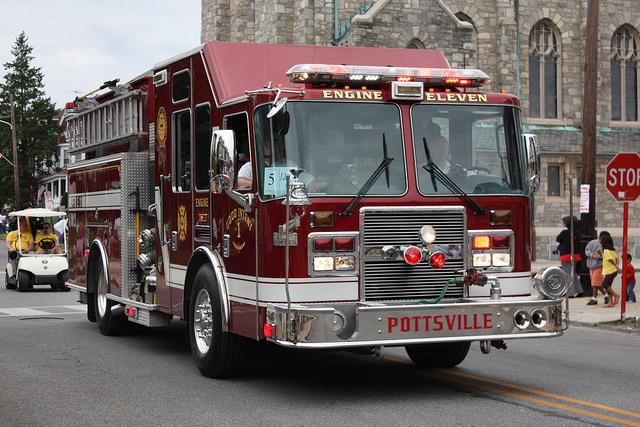Which side of the road is the fire truck driving on?

Choices:
A) middle
B) left
C) sidewalk
D) right middle 